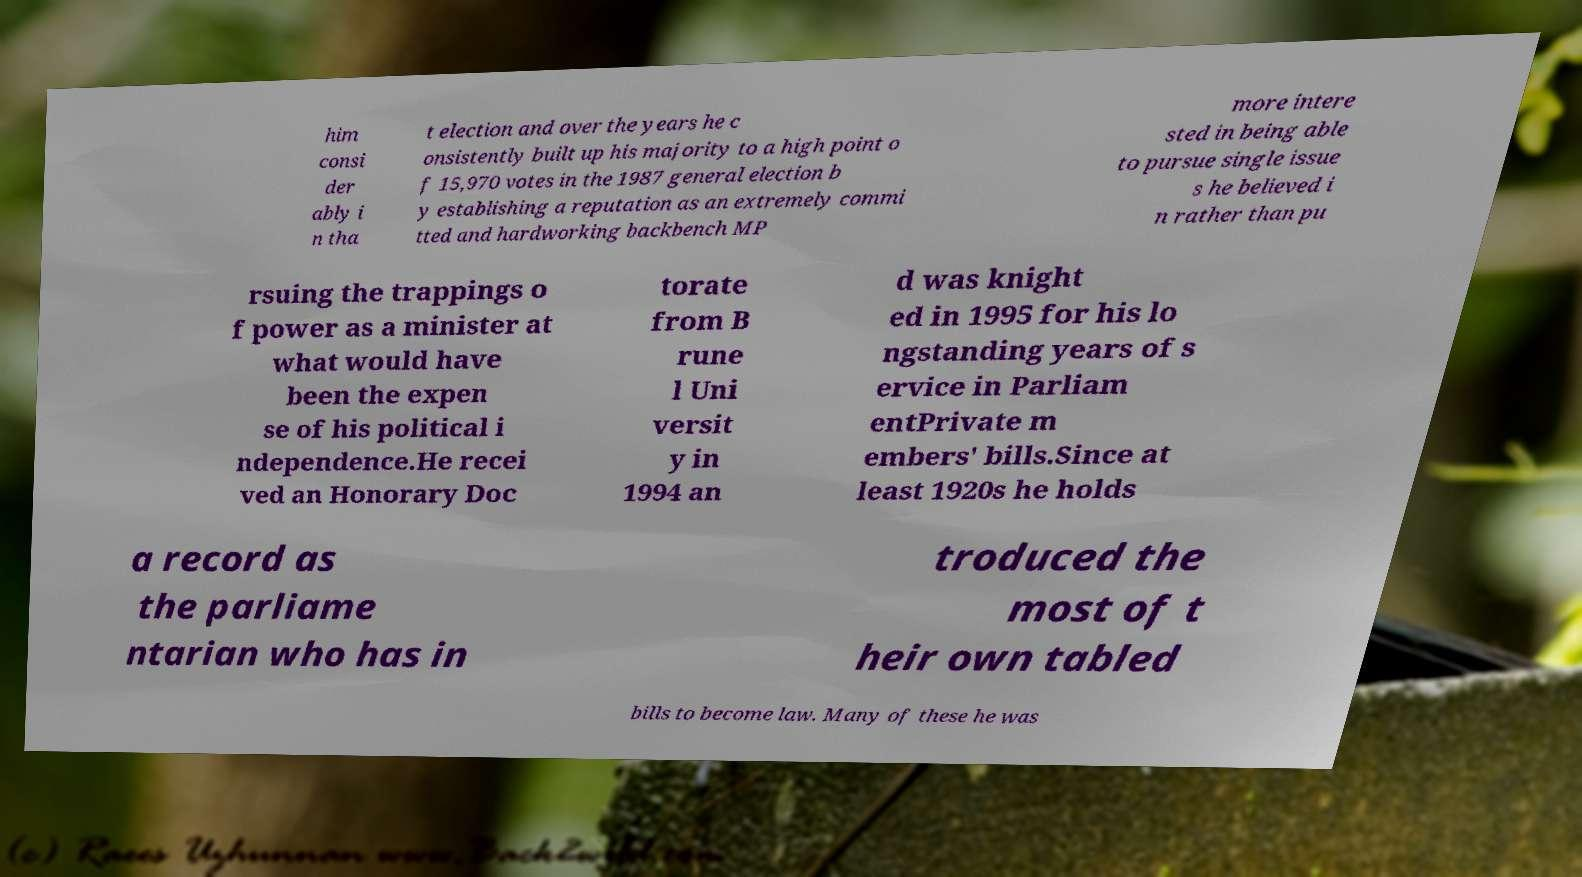Can you read and provide the text displayed in the image?This photo seems to have some interesting text. Can you extract and type it out for me? him consi der ably i n tha t election and over the years he c onsistently built up his majority to a high point o f 15,970 votes in the 1987 general election b y establishing a reputation as an extremely commi tted and hardworking backbench MP more intere sted in being able to pursue single issue s he believed i n rather than pu rsuing the trappings o f power as a minister at what would have been the expen se of his political i ndependence.He recei ved an Honorary Doc torate from B rune l Uni versit y in 1994 an d was knight ed in 1995 for his lo ngstanding years of s ervice in Parliam entPrivate m embers' bills.Since at least 1920s he holds a record as the parliame ntarian who has in troduced the most of t heir own tabled bills to become law. Many of these he was 